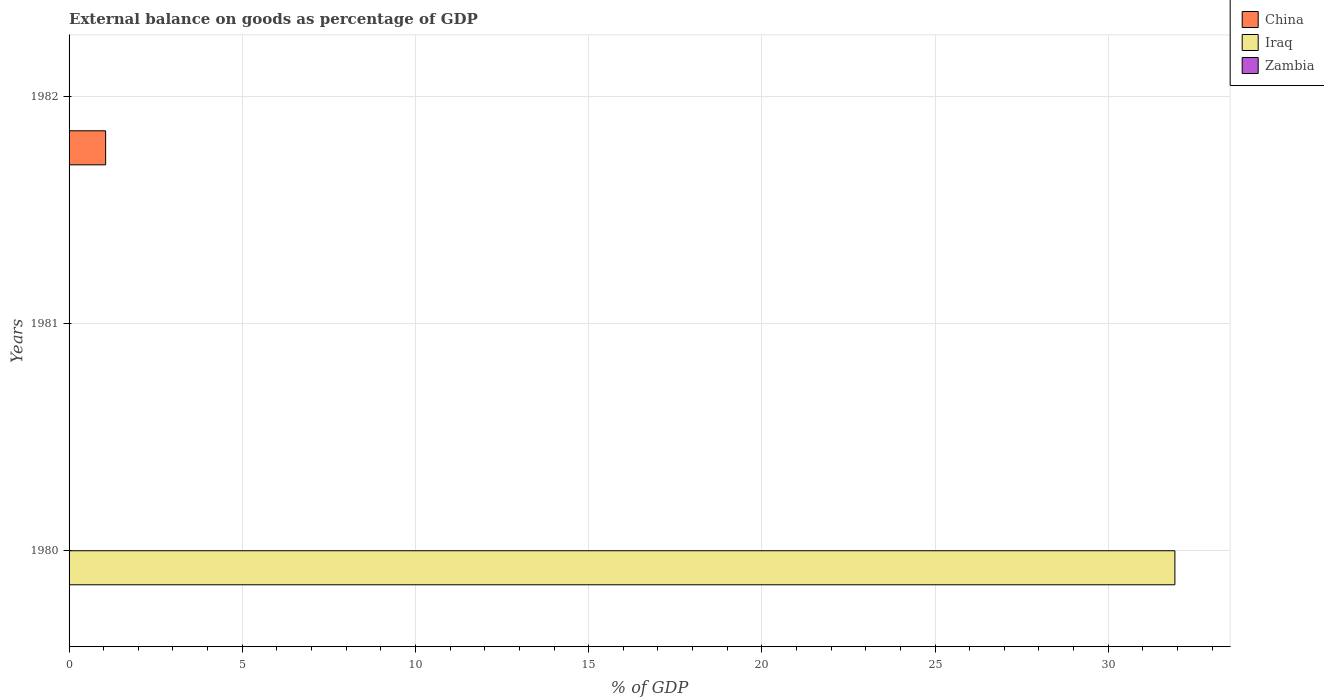How many different coloured bars are there?
Keep it short and to the point. 2. Are the number of bars per tick equal to the number of legend labels?
Make the answer very short. No. How many bars are there on the 1st tick from the top?
Offer a very short reply. 1. What is the label of the 3rd group of bars from the top?
Offer a very short reply. 1980. What is the external balance on goods as percentage of GDP in Iraq in 1981?
Provide a short and direct response. 0. Across all years, what is the maximum external balance on goods as percentage of GDP in Iraq?
Offer a very short reply. 31.93. In which year was the external balance on goods as percentage of GDP in Iraq maximum?
Keep it short and to the point. 1980. What is the total external balance on goods as percentage of GDP in Iraq in the graph?
Ensure brevity in your answer.  31.93. In how many years, is the external balance on goods as percentage of GDP in China greater than 23 %?
Offer a very short reply. 0. What is the difference between the highest and the lowest external balance on goods as percentage of GDP in Iraq?
Offer a very short reply. 31.93. How many bars are there?
Provide a short and direct response. 2. How many years are there in the graph?
Provide a succinct answer. 3. Are the values on the major ticks of X-axis written in scientific E-notation?
Offer a terse response. No. How are the legend labels stacked?
Offer a terse response. Vertical. What is the title of the graph?
Ensure brevity in your answer.  External balance on goods as percentage of GDP. What is the label or title of the X-axis?
Ensure brevity in your answer.  % of GDP. What is the % of GDP of China in 1980?
Keep it short and to the point. 0. What is the % of GDP in Iraq in 1980?
Make the answer very short. 31.93. What is the % of GDP of China in 1981?
Make the answer very short. 0. What is the % of GDP in Iraq in 1981?
Your answer should be compact. 0. What is the % of GDP of China in 1982?
Offer a terse response. 1.06. What is the % of GDP in Iraq in 1982?
Offer a terse response. 0. Across all years, what is the maximum % of GDP in China?
Keep it short and to the point. 1.06. Across all years, what is the maximum % of GDP of Iraq?
Your answer should be compact. 31.93. Across all years, what is the minimum % of GDP of Iraq?
Your answer should be very brief. 0. What is the total % of GDP of China in the graph?
Offer a terse response. 1.06. What is the total % of GDP of Iraq in the graph?
Give a very brief answer. 31.93. What is the total % of GDP in Zambia in the graph?
Your response must be concise. 0. What is the average % of GDP of China per year?
Offer a very short reply. 0.35. What is the average % of GDP of Iraq per year?
Ensure brevity in your answer.  10.64. What is the difference between the highest and the lowest % of GDP in China?
Keep it short and to the point. 1.06. What is the difference between the highest and the lowest % of GDP of Iraq?
Your response must be concise. 31.93. 